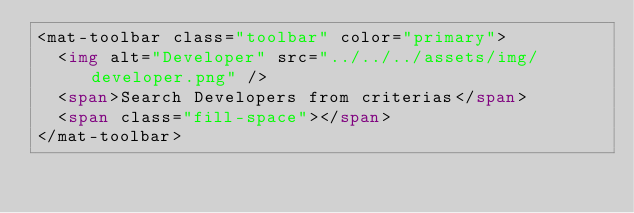<code> <loc_0><loc_0><loc_500><loc_500><_HTML_><mat-toolbar class="toolbar" color="primary">
  <img alt="Developer" src="../../../assets/img/developer.png" />
  <span>Search Developers from criterias</span>
  <span class="fill-space"></span>
</mat-toolbar>
</code> 